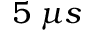Convert formula to latex. <formula><loc_0><loc_0><loc_500><loc_500>5 \, \mu s</formula> 